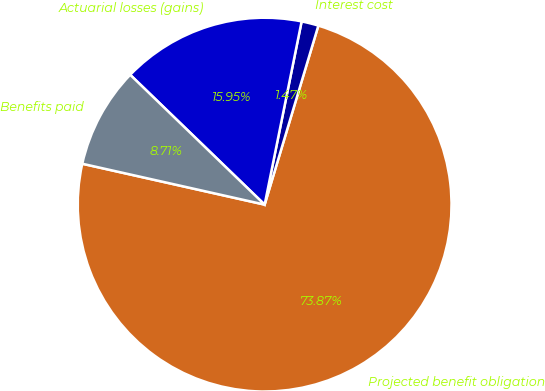<chart> <loc_0><loc_0><loc_500><loc_500><pie_chart><fcel>Projected benefit obligation<fcel>Interest cost<fcel>Actuarial losses (gains)<fcel>Benefits paid<nl><fcel>73.87%<fcel>1.47%<fcel>15.95%<fcel>8.71%<nl></chart> 